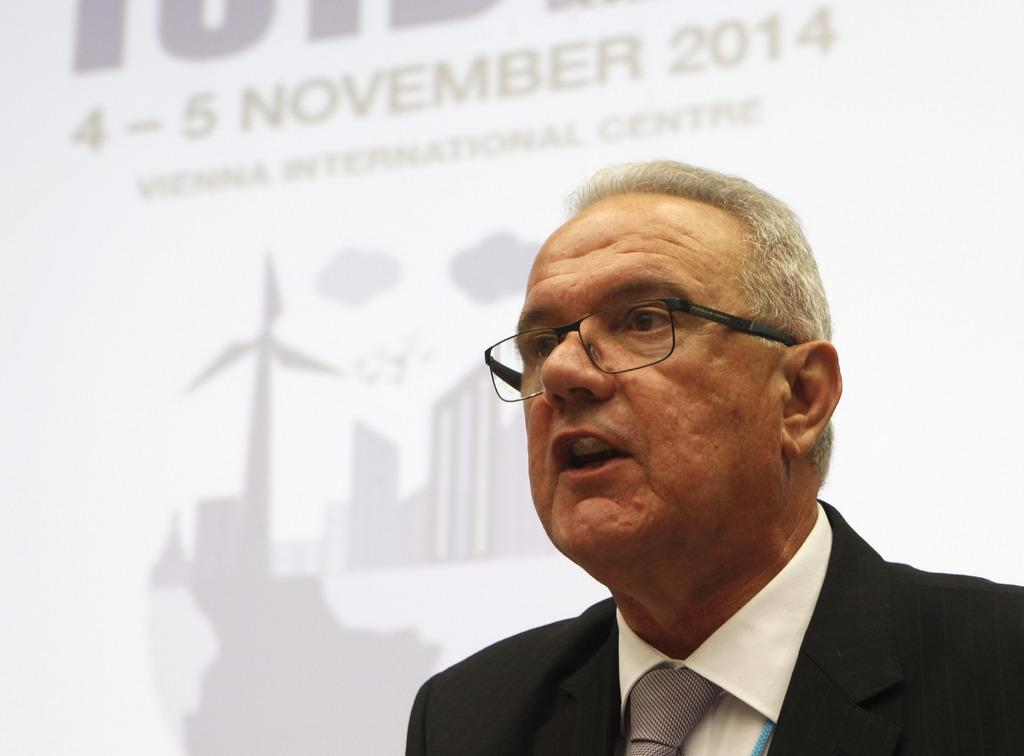Who is present in the image? There is a person in the image. What can be seen on the person's face? The person is wearing spectacles. What is visible in the background of the image? There is a poster in the background of the image. What type of content is present on the poster? The poster contains text and images. How does the person in the image order a meal? There is no indication in the image that the person is ordering a meal, so it cannot be determined from the picture. 